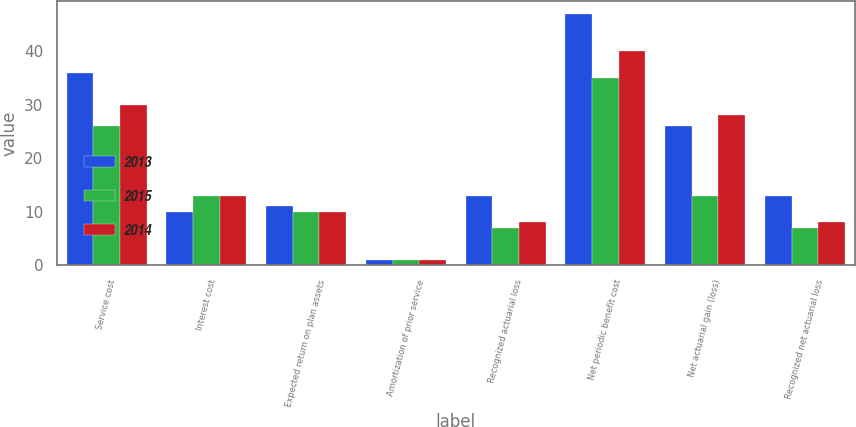<chart> <loc_0><loc_0><loc_500><loc_500><stacked_bar_chart><ecel><fcel>Service cost<fcel>Interest cost<fcel>Expected return on plan assets<fcel>Amortization of prior service<fcel>Recognized actuarial loss<fcel>Net periodic benefit cost<fcel>Net actuarial gain (loss)<fcel>Recognized net actuarial loss<nl><fcel>2013<fcel>36<fcel>10<fcel>11<fcel>1<fcel>13<fcel>47<fcel>26<fcel>13<nl><fcel>2015<fcel>26<fcel>13<fcel>10<fcel>1<fcel>7<fcel>35<fcel>13<fcel>7<nl><fcel>2014<fcel>30<fcel>13<fcel>10<fcel>1<fcel>8<fcel>40<fcel>28<fcel>8<nl></chart> 